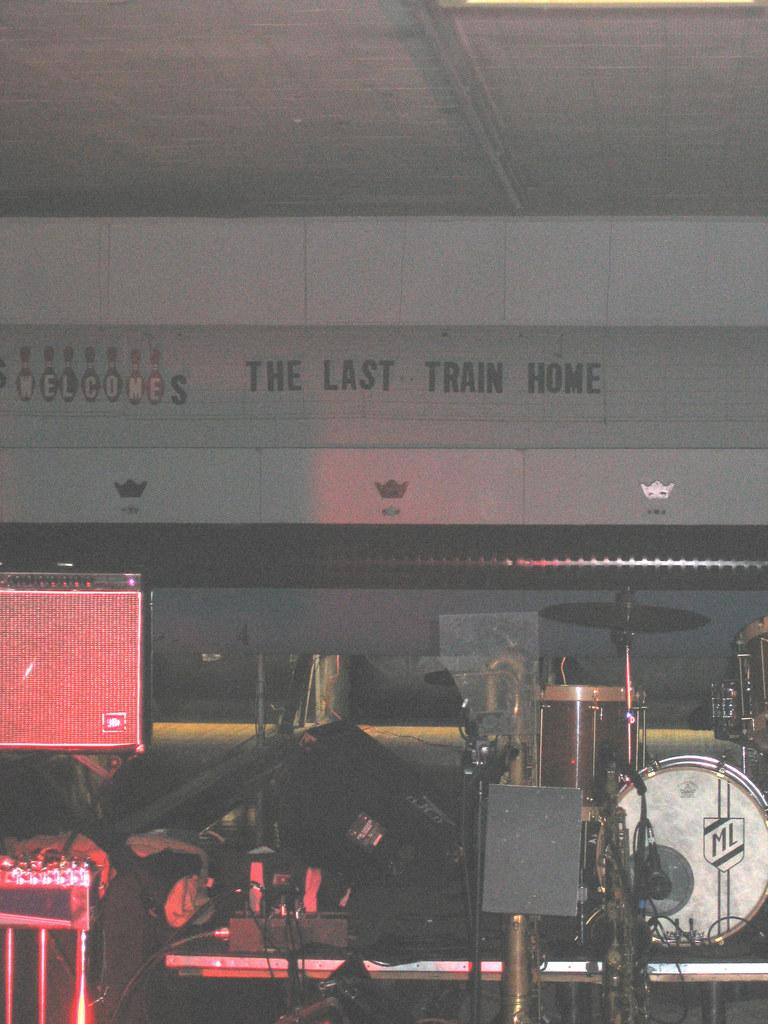What type of group is performing in the image? There is a music band in the image. Where is the music band performing? The music band is on a stage. Can you identify any specific instruments in the image? There is a music instrument on the left side of the image. What can be seen in the background of the image? There is a white-colored roofing shed in the background of the image. How many sticks are being used by the donkey in the image? There is no donkey present in the image, and therefore no sticks being used by a donkey. 